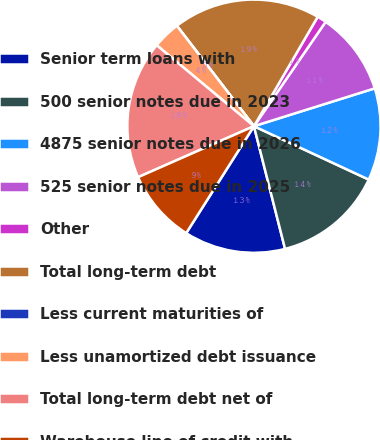Convert chart. <chart><loc_0><loc_0><loc_500><loc_500><pie_chart><fcel>Senior term loans with<fcel>500 senior notes due in 2023<fcel>4875 senior notes due in 2026<fcel>525 senior notes due in 2025<fcel>Other<fcel>Total long-term debt<fcel>Less current maturities of<fcel>Less unamortized debt issuance<fcel>Total long-term debt net of<fcel>Warehouse line of credit with<nl><fcel>12.94%<fcel>14.12%<fcel>11.76%<fcel>10.59%<fcel>1.18%<fcel>18.82%<fcel>0.0%<fcel>3.53%<fcel>17.65%<fcel>9.41%<nl></chart> 